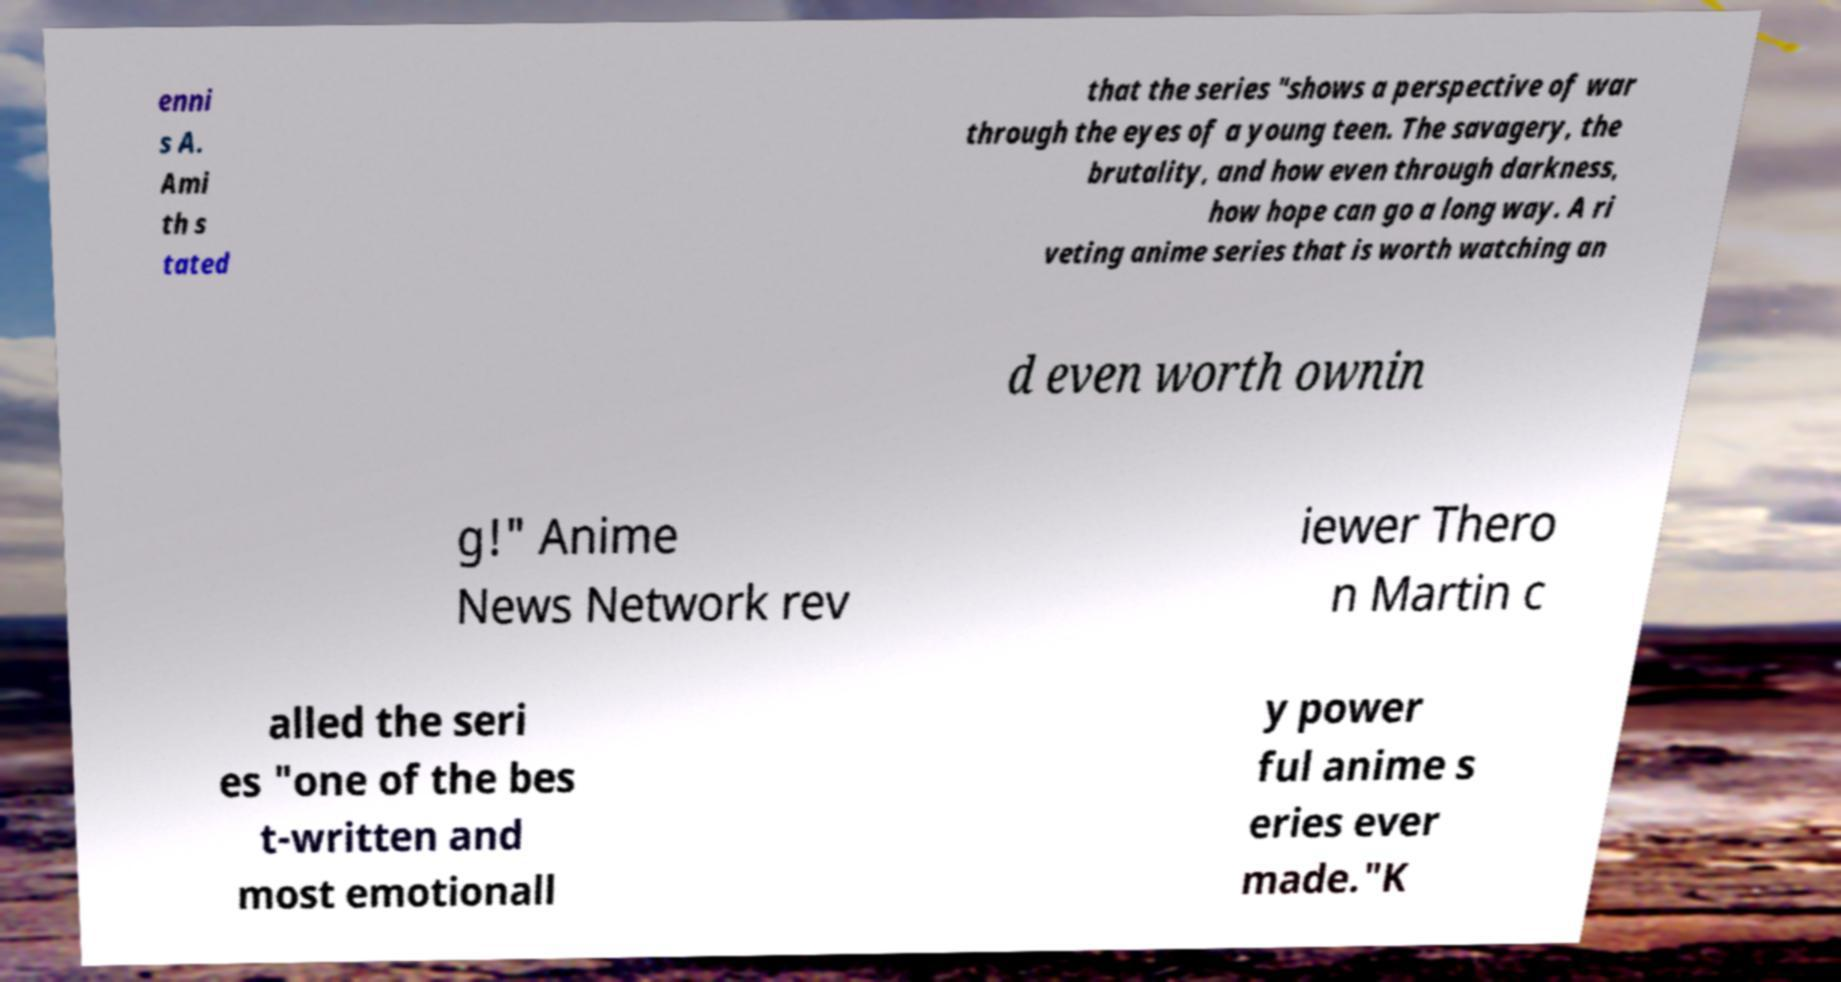There's text embedded in this image that I need extracted. Can you transcribe it verbatim? enni s A. Ami th s tated that the series "shows a perspective of war through the eyes of a young teen. The savagery, the brutality, and how even through darkness, how hope can go a long way. A ri veting anime series that is worth watching an d even worth ownin g!" Anime News Network rev iewer Thero n Martin c alled the seri es "one of the bes t-written and most emotionall y power ful anime s eries ever made."K 